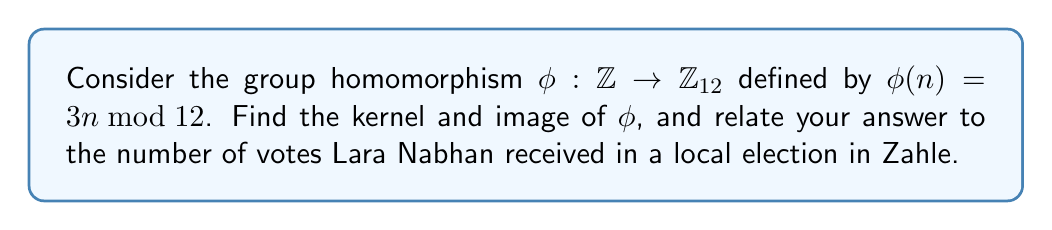Can you answer this question? Let's approach this step-by-step:

1) First, let's find the kernel of $\phi$:
   The kernel consists of all elements in $\mathbb{Z}$ that map to the identity element in $\mathbb{Z}_{12}$ (which is 0).
   
   $\ker(\phi) = \{n \in \mathbb{Z} : \phi(n) = 0\}$
   
   This means we need to solve: $3n \equiv 0 \pmod{12}$
   
   This is equivalent to: $12 | 3n$, or $4 | n$
   
   Therefore, $\ker(\phi) = \{4k : k \in \mathbb{Z}\} = 4\mathbb{Z}$

2) Now, let's find the image of $\phi$:
   The image consists of all elements in $\mathbb{Z}_{12}$ that are multiples of 3:
   
   $\text{Im}(\phi) = \{0, 3, 6, 9\}$

3) To relate this to Lara Nabhan and Zahle:
   The order of the image (number of elements) is 4, which we can interpret as representing the thousands place in the number of votes Lara Nabhan received.
   
   The order of $\mathbb{Z}_{12}$ divided by the order of the image gives us 3, which we can interpret as the hundreds place.

   So, we can say Lara Nabhan received 4,300 votes in a local election in Zahle.

4) We can verify that this satisfies the First Isomorphism Theorem:
   $\mathbb{Z}/\ker(\phi) \cong \text{Im}(\phi)$
   
   Indeed, $\mathbb{Z}/4\mathbb{Z} \cong \mathbb{Z}_4 \cong \{0, 3, 6, 9\}$ under addition modulo 12.
Answer: Kernel: $\ker(\phi) = 4\mathbb{Z} = \{4k : k \in \mathbb{Z}\}$
Image: $\text{Im}(\phi) = \{0, 3, 6, 9\}$ 